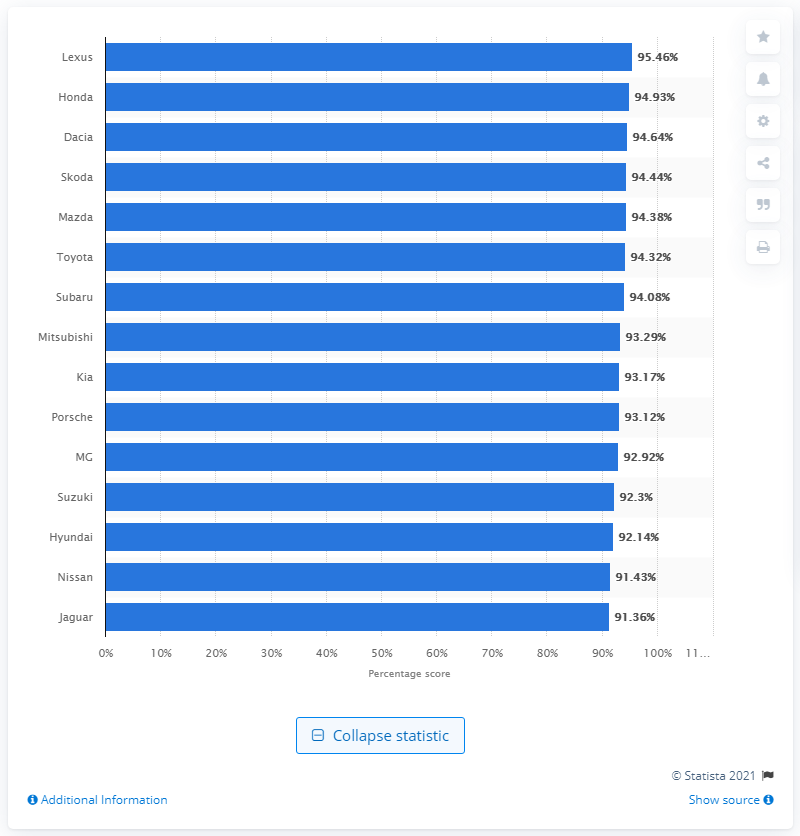Mention a couple of crucial points in this snapshot. In the 2014 Auto Express Driver Power survey, Dacia placed second and third in the car brand rankings. Lexus is the car brand that ranked first in terms of reliability. 